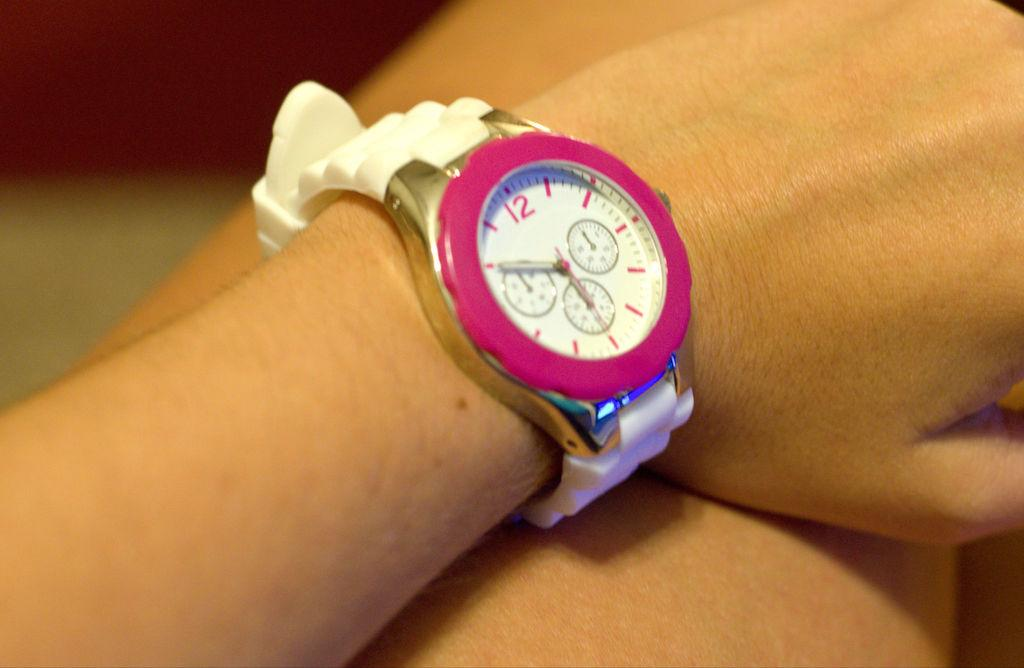<image>
Present a compact description of the photo's key features. Pink and white watch which has the number 12 on the top. 